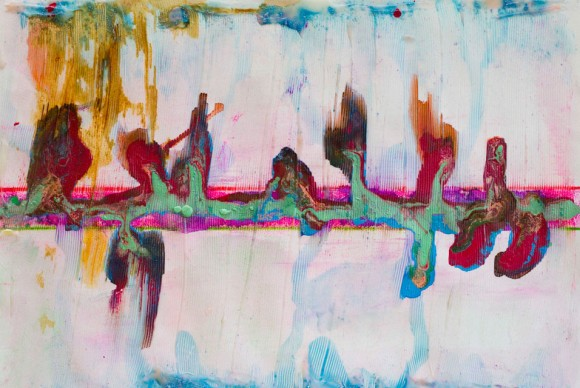If you were to turn this abstract painting into a musical composition, what instruments and genres would you use? To transform this abstract painting into a musical composition, I would envision a blend of ambient and classical music. The predominant pastel colors suggest gentle, serene melodies played by soft strings and a grand piano, evoking a feeling of calm. The occasional darker shades add depth and contrast, introduced by lower-pitched instruments like cellos and bassoons. Percussive instruments, such as softly played cymbals and chimes, would add texture reminiscent of the painting's visual texture. The blend of these elements would create an immersive auditory experience that mirrors the intricate and layered quality of the artwork. Describe this painting as a landscape in a dream world. In a dream world, this painting translates into an otherworldly landscape that defies conventional geography. The horizon is a blend of soft pastel clouds, gently folding into each other, creating a sky that feels both boundless and comforting. Below, undulating hills and valleys are painted in streaks of vibrant colors, flowing like rivers of paint. Pockets of darker tones form mysterious caves and shaded groves, adding intrigue and places to explore. Bright, ethereal foliage grows in unexpected shapes, with colors that shift as if breathing with life. This dreamscape feels fluid and ever-changing, encouraging the dreamer to wander endlessly through a realm of infinite possibilities and vibrant beauty. 